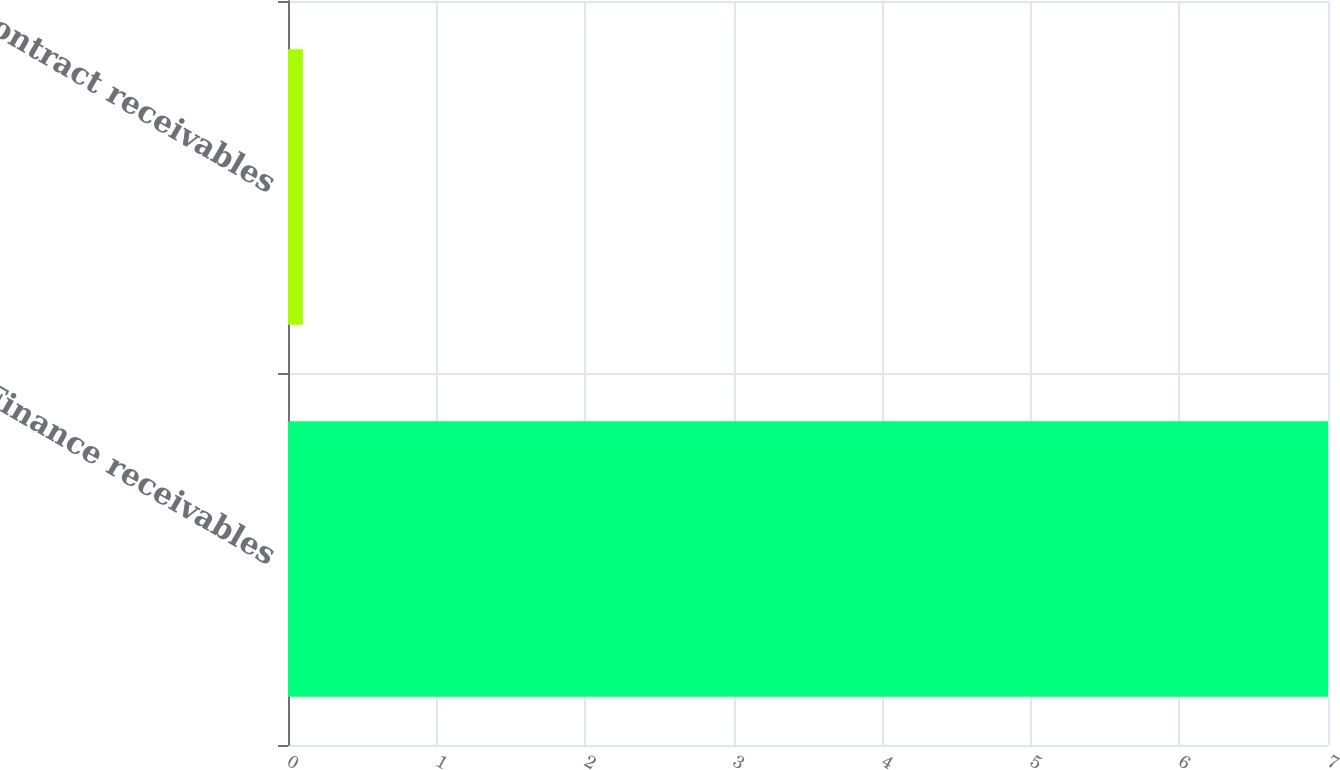Convert chart. <chart><loc_0><loc_0><loc_500><loc_500><bar_chart><fcel>Finance receivables<fcel>Contract receivables<nl><fcel>7<fcel>0.1<nl></chart> 